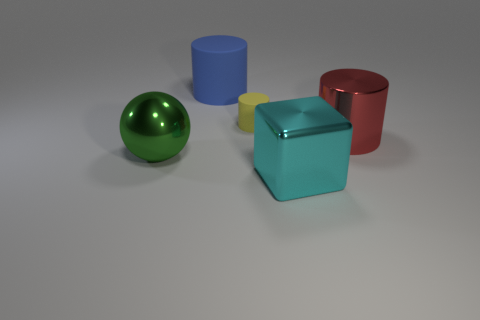What number of large things are green balls or red metallic objects?
Your answer should be compact. 2. There is a shiny object that is in front of the green object; is it the same color as the big metal thing that is left of the large blue object?
Your answer should be compact. No. How many other things are there of the same color as the large metallic cylinder?
Ensure brevity in your answer.  0. How many green objects are metal blocks or tiny metal blocks?
Offer a very short reply. 0. Does the big red metal thing have the same shape as the yellow object behind the large cyan metallic object?
Provide a succinct answer. Yes. What shape is the small object?
Your response must be concise. Cylinder. What material is the green ball that is the same size as the red shiny cylinder?
Provide a succinct answer. Metal. Is there anything else that is the same size as the cyan metal object?
Make the answer very short. Yes. What number of objects are big green things or things that are to the right of the cyan metallic object?
Offer a very short reply. 2. What is the size of the green thing that is made of the same material as the big red cylinder?
Your answer should be compact. Large. 